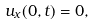<formula> <loc_0><loc_0><loc_500><loc_500>u _ { x } ( 0 , t ) = 0 ,</formula> 